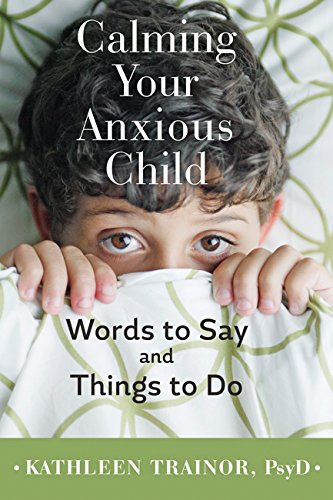Is this a transportation engineering book? No, this book is not related to transportation engineering; it is a self-help book focused on managing anxiety in children. 